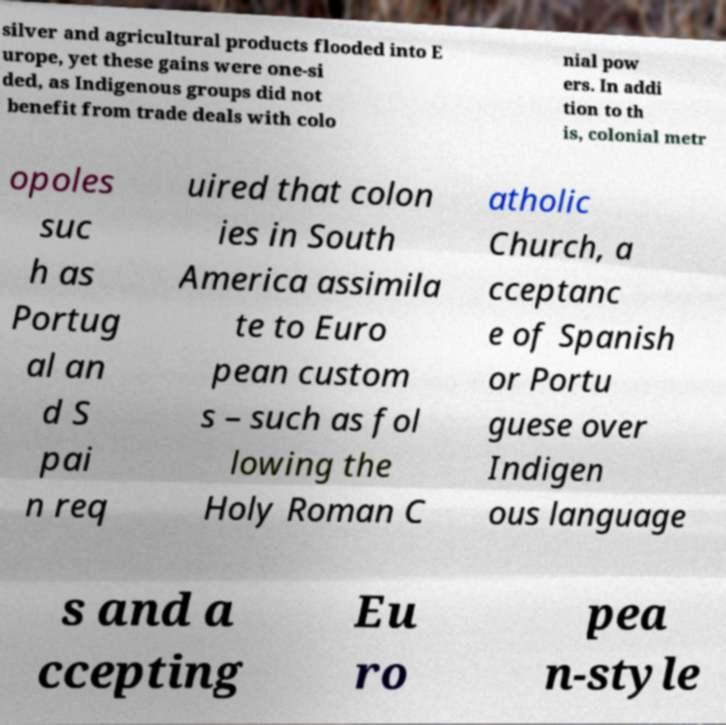Could you extract and type out the text from this image? silver and agricultural products flooded into E urope, yet these gains were one-si ded, as Indigenous groups did not benefit from trade deals with colo nial pow ers. In addi tion to th is, colonial metr opoles suc h as Portug al an d S pai n req uired that colon ies in South America assimila te to Euro pean custom s – such as fol lowing the Holy Roman C atholic Church, a cceptanc e of Spanish or Portu guese over Indigen ous language s and a ccepting Eu ro pea n-style 